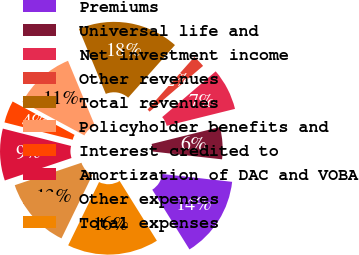<chart> <loc_0><loc_0><loc_500><loc_500><pie_chart><fcel>Premiums<fcel>Universal life and<fcel>Net investment income<fcel>Other revenues<fcel>Total revenues<fcel>Policyholder benefits and<fcel>Interest credited to<fcel>Amortization of DAC and VOBA<fcel>Other expenses<fcel>Total expenses<nl><fcel>14.35%<fcel>5.65%<fcel>7.39%<fcel>2.17%<fcel>17.83%<fcel>10.87%<fcel>3.91%<fcel>9.13%<fcel>12.61%<fcel>16.09%<nl></chart> 